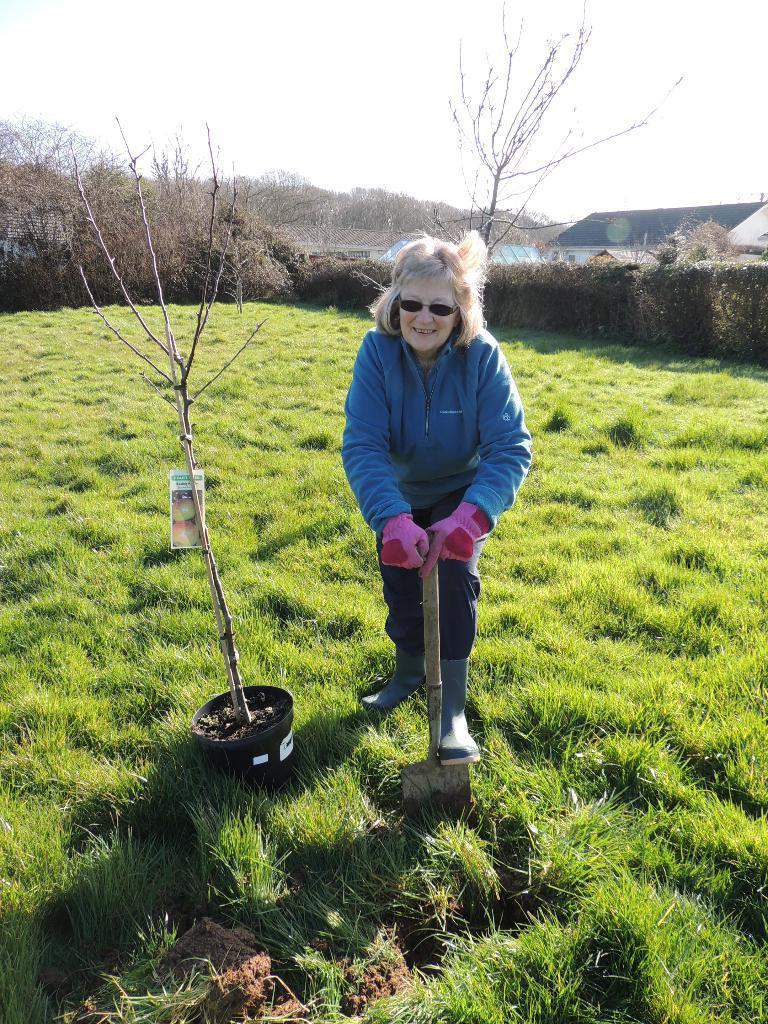Could you give a brief overview of what you see in this image? In this image there is the sky truncated towards the top of the image, there are trees truncated towards the left of the image, there is the grass truncated, there is a flower pot on the grass, there is a plant, there is an object on the plant, there are plants truncated towards the right of the image, there is a building truncated towards the right of the image, there is a person standing and holding an object, there is grass truncated towards the right of the image, there is grass truncated towards the bottom of the image. 